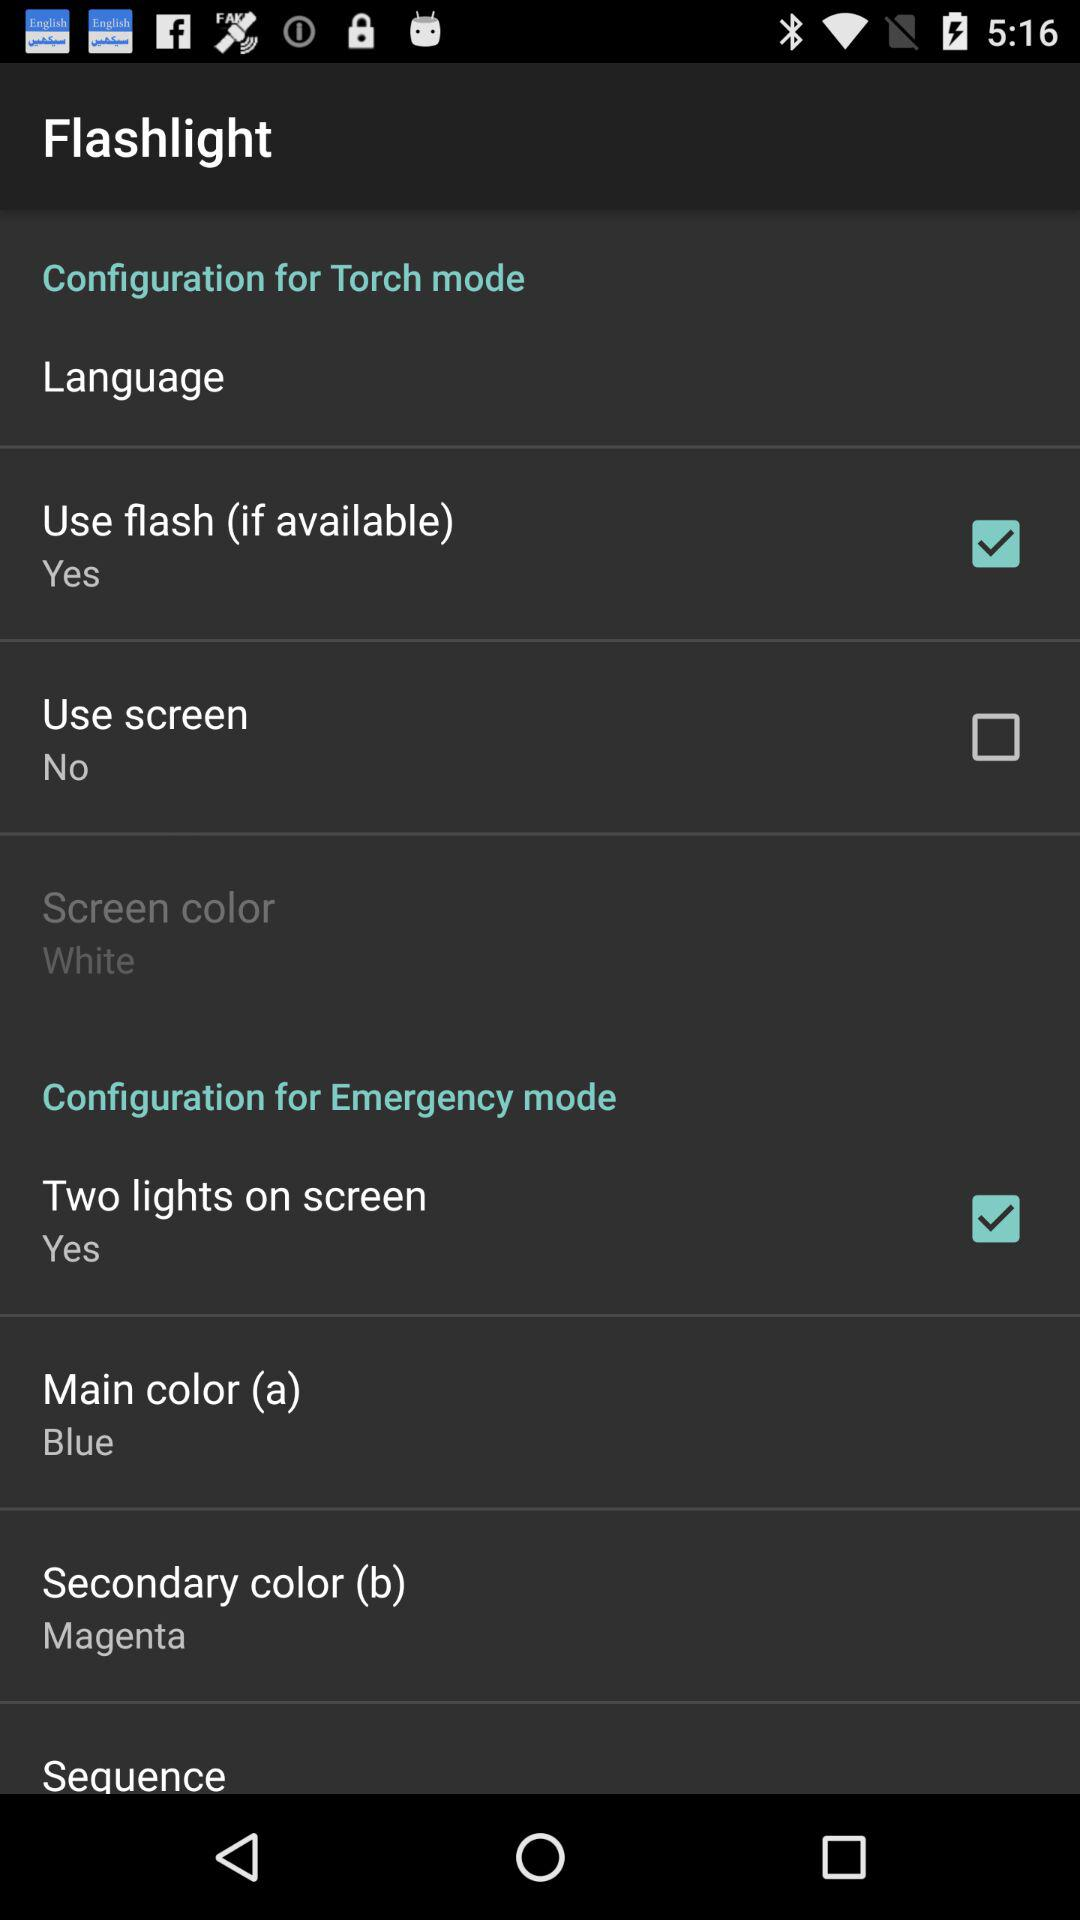What is the main color (a)? The main color (a) is blue. 